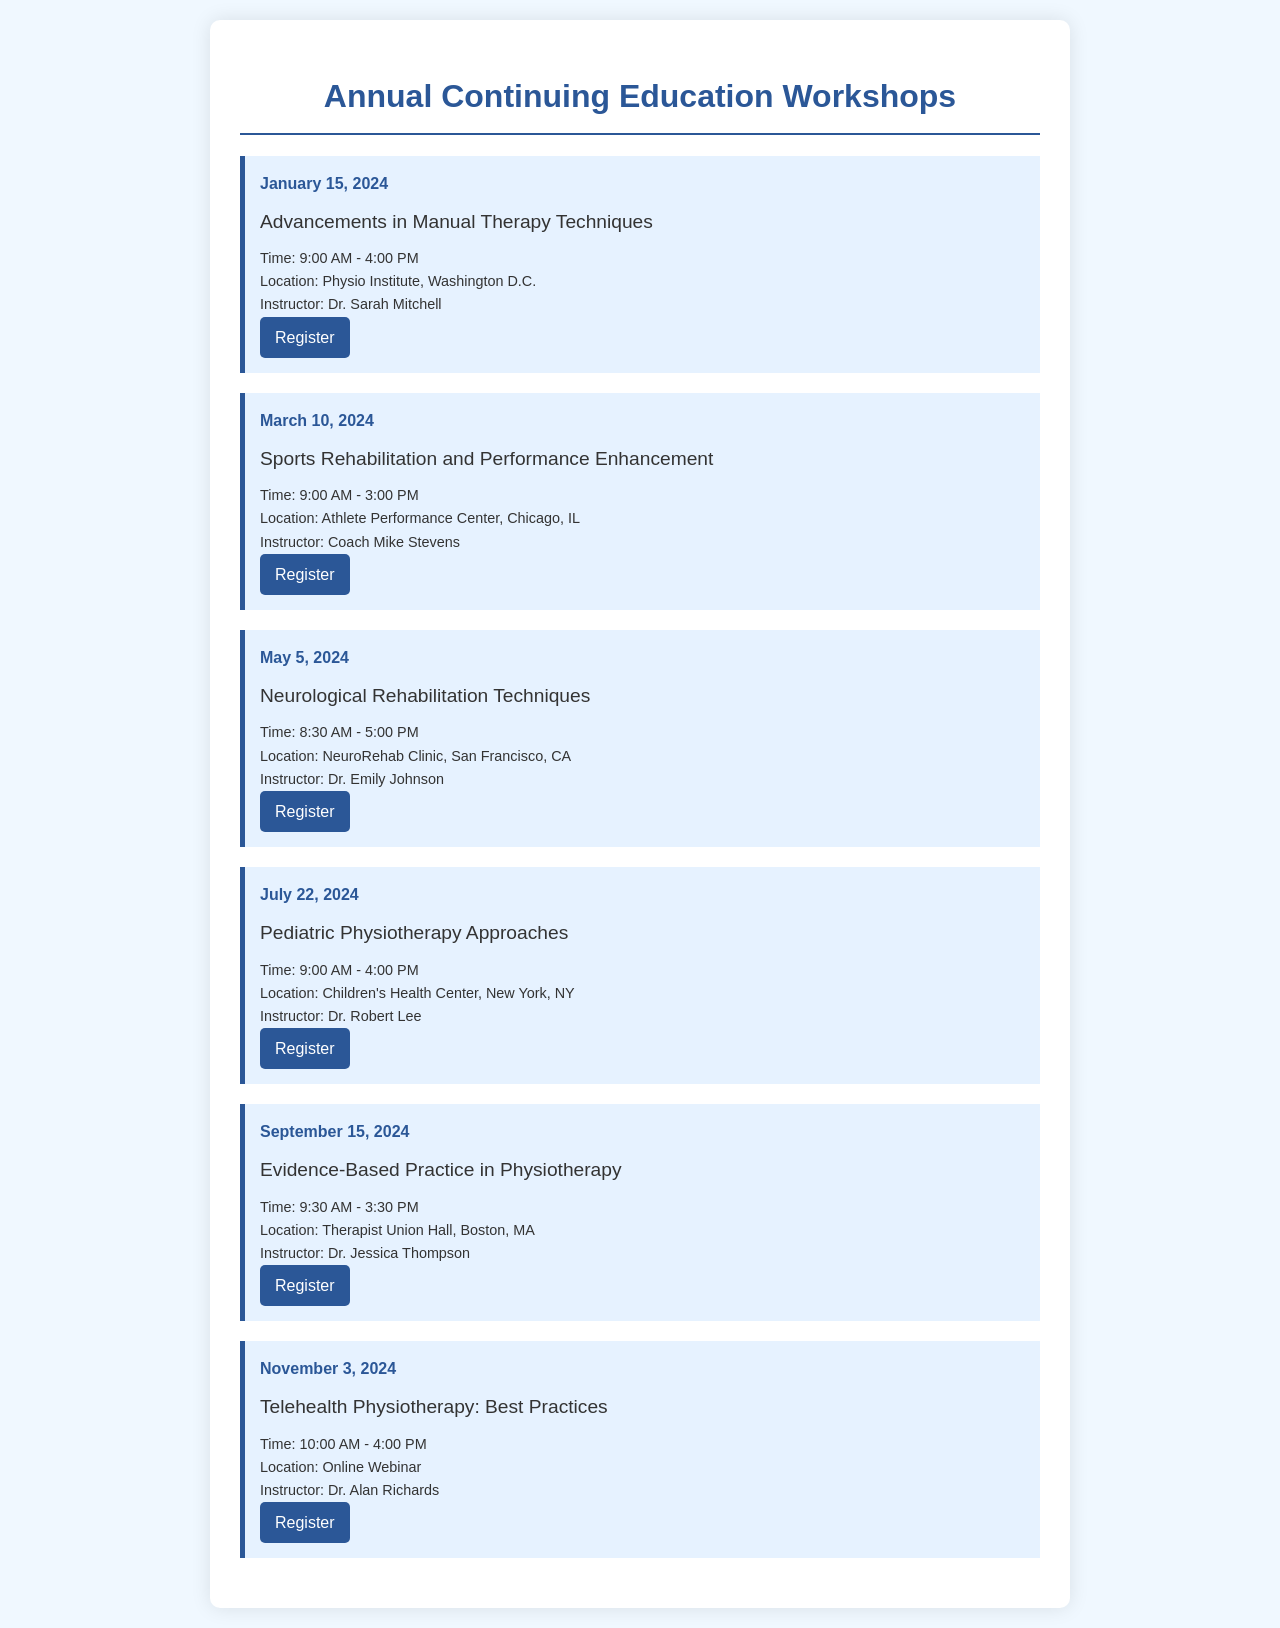what is the date of the first workshop? The first workshop is scheduled for January 15, 2024.
Answer: January 15, 2024 who is the instructor for the workshop on Sports Rehabilitation? The instructor for the Sports Rehabilitation workshop is Coach Mike Stevens.
Answer: Coach Mike Stevens what is the location of the Pediatric Physiotherapy Approaches workshop? The Pediatric Physiotherapy Approaches workshop will take place at the Children's Health Center in New York, NY.
Answer: Children's Health Center, New York, NY how long is the Neurological Rehabilitation Techniques workshop? The Neurological Rehabilitation Techniques workshop runs for 8.5 hours, from 8:30 AM to 5:00 PM.
Answer: 8.5 hours what is the topic of the workshop held on November 3, 2024? The workshop on November 3, 2024, will cover Telehealth Physiotherapy: Best Practices.
Answer: Telehealth Physiotherapy: Best Practices which workshop has the latest date in the calendar? The latest date in the calendar is November 3, 2024.
Answer: November 3, 2024 what time does the Evidence-Based Practice in Physiotherapy workshop start? The Evidence-Based Practice in Physiotherapy workshop starts at 9:30 AM.
Answer: 9:30 AM where is the instructor for the first workshop from? The instructor for the first workshop, Dr. Sarah Mitchell, is from the Physio Institute in Washington D.C.
Answer: Physio Institute, Washington D.C 